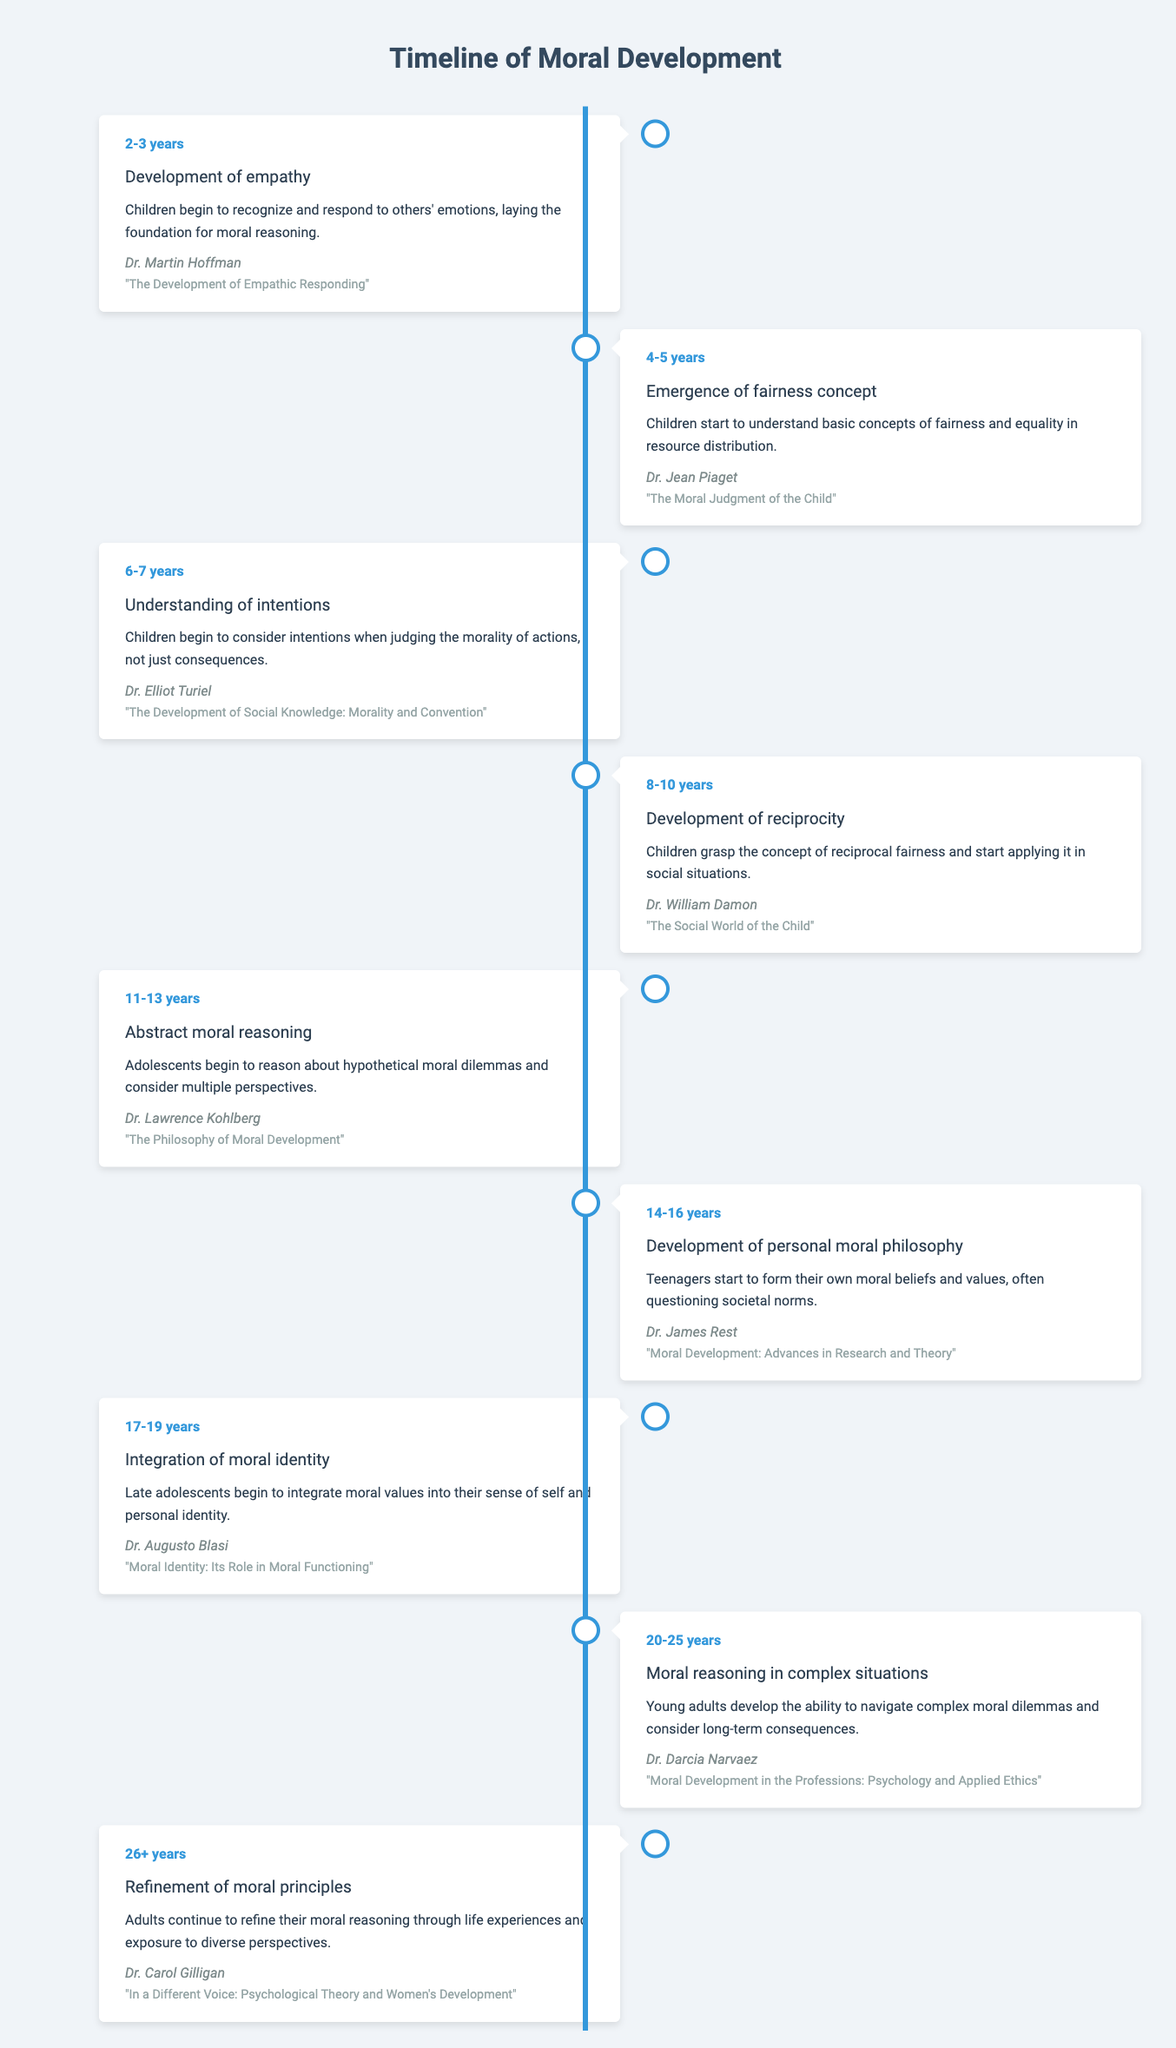What milestone occurs at the age of 11-13 years? The milestone listed for the age of 11-13 years is "Abstract moral reasoning." This information can be directly retrieved from the timeline table.
Answer: Abstract moral reasoning Who conducted the study on the development of empathy? According to the table, Dr. Martin Hoffman conducted the study on the development of empathy. This can be directly referenced from the entry for ages 2-3 years.
Answer: Dr. Martin Hoffman Is the concept of fairness understood by children aged 4-5 years? Yes, the table states that at ages 4-5 years, children begin to understand basic concepts of fairness and equality in resource distribution.
Answer: Yes What is the age range during which integration of moral identity occurs? The age range for the integration of moral identity is given as 17-19 years in the timeline. This can be found directly in the corresponding entry.
Answer: 17-19 years How many milestones are related to the ages 14-16 years? There is one milestone related to the ages 14-16 years: "Development of personal moral philosophy." To answer this, we refer to the specific entry for that age range in the timeline and note that there is only one listed milestone.
Answer: 1 At what age do children start grasping the concept of reciprocity? The timeline indicates that children begin to understand the concept of reciprocity between ages 8-10 years. This is a direct retrieval question from the relevant entry.
Answer: 8-10 years What is the relationship between the ages 20-25 years and moral reasoning in complex situations? The table specifies that between ages 20-25 years, young adults develop the ability to navigate complex moral dilemmas. Thus, the relationship is that this age group is associated with the development of moral reasoning in complex situations.
Answer: Young adults learn to navigate complex moral dilemmas What is the difference in age between the development of empathy and the integration of moral identity? The development of empathy occurs at ages 2-3 years and the integration of moral identity occurs at ages 17-19 years. To find the difference, we calculate: 17 - 3 = 14. Therefore, the difference in age is 14 years.
Answer: 14 years Is it true that researchers have studied moral reasoning as early as 2-3 years? Yes, the timeline indicates that the development of empathy, which is a precursor to moral reasoning, is identified as occurring at ages 2-3 years. This information directly supports the fact that studies on moral reasoning have indeed looked at this early age.
Answer: Yes 